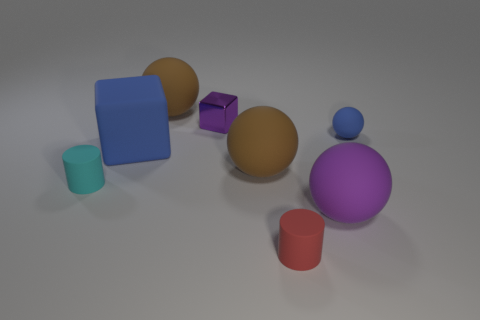Subtract all purple cylinders. How many brown spheres are left? 2 Subtract all tiny matte balls. How many balls are left? 3 Subtract all purple balls. How many balls are left? 3 Add 1 tiny yellow things. How many objects exist? 9 Subtract all cyan spheres. Subtract all purple cubes. How many spheres are left? 4 Subtract all cylinders. How many objects are left? 6 Add 6 gray spheres. How many gray spheres exist? 6 Subtract 0 blue cylinders. How many objects are left? 8 Subtract all large gray blocks. Subtract all big purple spheres. How many objects are left? 7 Add 1 shiny things. How many shiny things are left? 2 